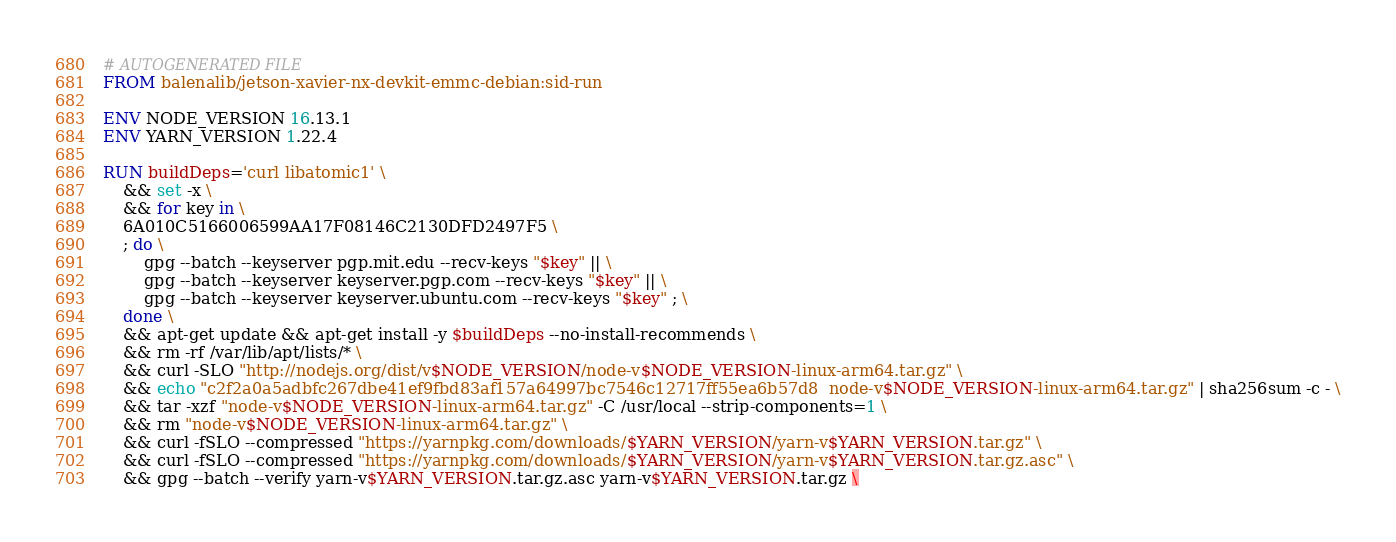<code> <loc_0><loc_0><loc_500><loc_500><_Dockerfile_># AUTOGENERATED FILE
FROM balenalib/jetson-xavier-nx-devkit-emmc-debian:sid-run

ENV NODE_VERSION 16.13.1
ENV YARN_VERSION 1.22.4

RUN buildDeps='curl libatomic1' \
	&& set -x \
	&& for key in \
	6A010C5166006599AA17F08146C2130DFD2497F5 \
	; do \
		gpg --batch --keyserver pgp.mit.edu --recv-keys "$key" || \
		gpg --batch --keyserver keyserver.pgp.com --recv-keys "$key" || \
		gpg --batch --keyserver keyserver.ubuntu.com --recv-keys "$key" ; \
	done \
	&& apt-get update && apt-get install -y $buildDeps --no-install-recommends \
	&& rm -rf /var/lib/apt/lists/* \
	&& curl -SLO "http://nodejs.org/dist/v$NODE_VERSION/node-v$NODE_VERSION-linux-arm64.tar.gz" \
	&& echo "c2f2a0a5adbfc267dbe41ef9fbd83af157a64997bc7546c12717ff55ea6b57d8  node-v$NODE_VERSION-linux-arm64.tar.gz" | sha256sum -c - \
	&& tar -xzf "node-v$NODE_VERSION-linux-arm64.tar.gz" -C /usr/local --strip-components=1 \
	&& rm "node-v$NODE_VERSION-linux-arm64.tar.gz" \
	&& curl -fSLO --compressed "https://yarnpkg.com/downloads/$YARN_VERSION/yarn-v$YARN_VERSION.tar.gz" \
	&& curl -fSLO --compressed "https://yarnpkg.com/downloads/$YARN_VERSION/yarn-v$YARN_VERSION.tar.gz.asc" \
	&& gpg --batch --verify yarn-v$YARN_VERSION.tar.gz.asc yarn-v$YARN_VERSION.tar.gz \</code> 